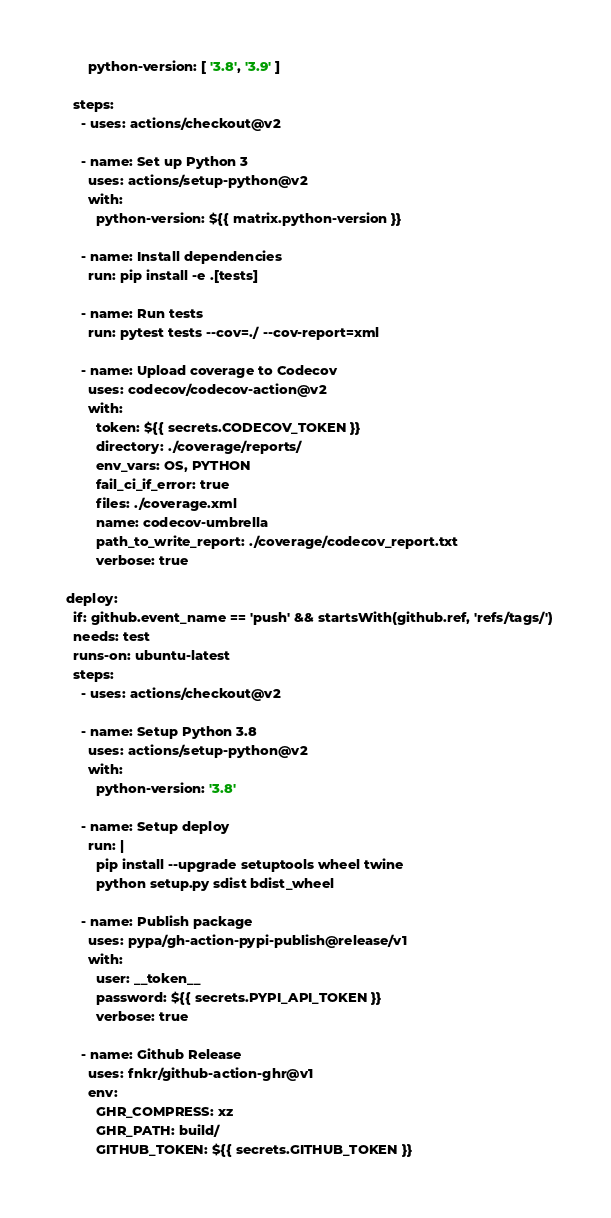Convert code to text. <code><loc_0><loc_0><loc_500><loc_500><_YAML_>        python-version: [ '3.8', '3.9' ]

    steps:
      - uses: actions/checkout@v2

      - name: Set up Python 3
        uses: actions/setup-python@v2
        with:
          python-version: ${{ matrix.python-version }}

      - name: Install dependencies
        run: pip install -e .[tests]

      - name: Run tests
        run: pytest tests --cov=./ --cov-report=xml

      - name: Upload coverage to Codecov
        uses: codecov/codecov-action@v2
        with:
          token: ${{ secrets.CODECOV_TOKEN }}
          directory: ./coverage/reports/
          env_vars: OS, PYTHON
          fail_ci_if_error: true
          files: ./coverage.xml
          name: codecov-umbrella
          path_to_write_report: ./coverage/codecov_report.txt
          verbose: true

  deploy:
    if: github.event_name == 'push' && startsWith(github.ref, 'refs/tags/')
    needs: test
    runs-on: ubuntu-latest
    steps:
      - uses: actions/checkout@v2
      
      - name: Setup Python 3.8
        uses: actions/setup-python@v2
        with:
          python-version: '3.8'

      - name: Setup deploy
        run: |
          pip install --upgrade setuptools wheel twine
          python setup.py sdist bdist_wheel

      - name: Publish package
        uses: pypa/gh-action-pypi-publish@release/v1
        with:
          user: __token__
          password: ${{ secrets.PYPI_API_TOKEN }}
          verbose: true

      - name: Github Release
        uses: fnkr/github-action-ghr@v1
        env:
          GHR_COMPRESS: xz
          GHR_PATH: build/
          GITHUB_TOKEN: ${{ secrets.GITHUB_TOKEN }}
</code> 